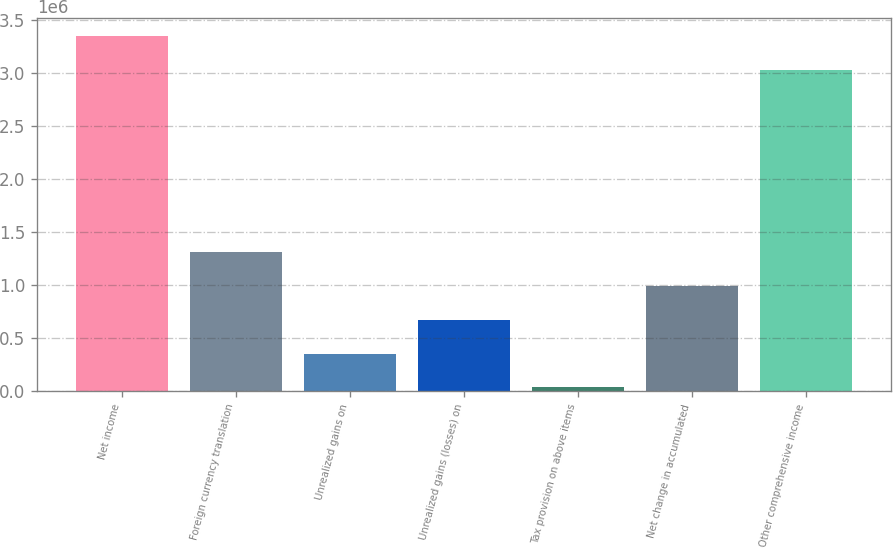<chart> <loc_0><loc_0><loc_500><loc_500><bar_chart><fcel>Net income<fcel>Foreign currency translation<fcel>Unrealized gains on<fcel>Unrealized gains (losses) on<fcel>Tax provision on above items<fcel>Net change in accumulated<fcel>Other comprehensive income<nl><fcel>3.34688e+06<fcel>1.31336e+06<fcel>355347<fcel>674685<fcel>36009<fcel>994022<fcel>3.02754e+06<nl></chart> 